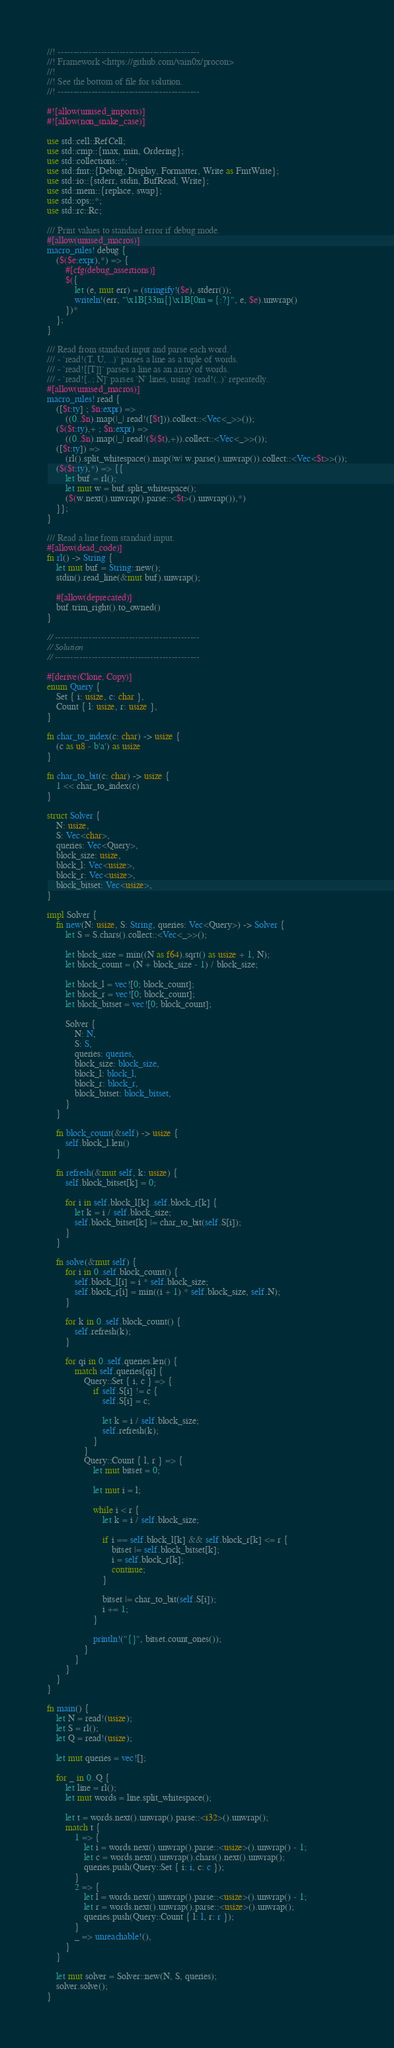<code> <loc_0><loc_0><loc_500><loc_500><_Rust_>//! ----------------------------------------------
//! Framework <https://github.com/vain0x/procon>
//!
//! See the bottom of file for solution.
//! ----------------------------------------------

#![allow(unused_imports)]
#![allow(non_snake_case)]

use std::cell::RefCell;
use std::cmp::{max, min, Ordering};
use std::collections::*;
use std::fmt::{Debug, Display, Formatter, Write as FmtWrite};
use std::io::{stderr, stdin, BufRead, Write};
use std::mem::{replace, swap};
use std::ops::*;
use std::rc::Rc;

/// Print values to standard error if debug mode.
#[allow(unused_macros)]
macro_rules! debug {
    ($($e:expr),*) => {
        #[cfg(debug_assertions)]
        $({
            let (e, mut err) = (stringify!($e), stderr());
            writeln!(err, "\x1B[33m{}\x1B[0m = {:?}", e, $e).unwrap()
        })*
    };
}

/// Read from standard input and parse each word.
/// - `read!(T, U, ..)` parses a line as a tuple of words.
/// - `read![[T]]` parses a line as an array of words.
/// - `read![..; N]` parses `N` lines, using `read!(..)` repeatedly.
#[allow(unused_macros)]
macro_rules! read {
    ([$t:ty] ; $n:expr) =>
        ((0..$n).map(|_| read!([$t])).collect::<Vec<_>>());
    ($($t:ty),+ ; $n:expr) =>
        ((0..$n).map(|_| read!($($t),+)).collect::<Vec<_>>());
    ([$t:ty]) =>
        (rl().split_whitespace().map(|w| w.parse().unwrap()).collect::<Vec<$t>>());
    ($($t:ty),*) => {{
        let buf = rl();
        let mut w = buf.split_whitespace();
        ($(w.next().unwrap().parse::<$t>().unwrap()),*)
    }};
}

/// Read a line from standard input.
#[allow(dead_code)]
fn rl() -> String {
    let mut buf = String::new();
    stdin().read_line(&mut buf).unwrap();

    #[allow(deprecated)]
    buf.trim_right().to_owned()
}

// -----------------------------------------------
// Solution
// -----------------------------------------------

#[derive(Clone, Copy)]
enum Query {
    Set { i: usize, c: char },
    Count { l: usize, r: usize },
}

fn char_to_index(c: char) -> usize {
    (c as u8 - b'a') as usize
}

fn char_to_bit(c: char) -> usize {
    1 << char_to_index(c)
}

struct Solver {
    N: usize,
    S: Vec<char>,
    queries: Vec<Query>,
    block_size: usize,
    block_l: Vec<usize>,
    block_r: Vec<usize>,
    block_bitset: Vec<usize>,
}

impl Solver {
    fn new(N: usize, S: String, queries: Vec<Query>) -> Solver {
        let S = S.chars().collect::<Vec<_>>();

        let block_size = min((N as f64).sqrt() as usize + 1, N);
        let block_count = (N + block_size - 1) / block_size;

        let block_l = vec![0; block_count];
        let block_r = vec![0; block_count];
        let block_bitset = vec![0; block_count];

        Solver {
            N: N,
            S: S,
            queries: queries,
            block_size: block_size,
            block_l: block_l,
            block_r: block_r,
            block_bitset: block_bitset,
        }
    }

    fn block_count(&self) -> usize {
        self.block_l.len()
    }

    fn refresh(&mut self, k: usize) {
        self.block_bitset[k] = 0;

        for i in self.block_l[k]..self.block_r[k] {
            let k = i / self.block_size;
            self.block_bitset[k] |= char_to_bit(self.S[i]);
        }
    }

    fn solve(&mut self) {
        for i in 0..self.block_count() {
            self.block_l[i] = i * self.block_size;
            self.block_r[i] = min((i + 1) * self.block_size, self.N);
        }

        for k in 0..self.block_count() {
            self.refresh(k);
        }

        for qi in 0..self.queries.len() {
            match self.queries[qi] {
                Query::Set { i, c } => {
                    if self.S[i] != c {
                        self.S[i] = c;

                        let k = i / self.block_size;
                        self.refresh(k);
                    }
                }
                Query::Count { l, r } => {
                    let mut bitset = 0;

                    let mut i = l;

                    while i < r {
                        let k = i / self.block_size;

                        if i == self.block_l[k] && self.block_r[k] <= r {
                            bitset |= self.block_bitset[k];
                            i = self.block_r[k];
                            continue;
                        }

                        bitset |= char_to_bit(self.S[i]);
                        i += 1;
                    }

                    println!("{}", bitset.count_ones());
                }
            }
        }
    }
}

fn main() {
    let N = read!(usize);
    let S = rl();
    let Q = read!(usize);

    let mut queries = vec![];

    for _ in 0..Q {
        let line = rl();
        let mut words = line.split_whitespace();

        let t = words.next().unwrap().parse::<i32>().unwrap();
        match t {
            1 => {
                let i = words.next().unwrap().parse::<usize>().unwrap() - 1;
                let c = words.next().unwrap().chars().next().unwrap();
                queries.push(Query::Set { i: i, c: c });
            }
            2 => {
                let l = words.next().unwrap().parse::<usize>().unwrap() - 1;
                let r = words.next().unwrap().parse::<usize>().unwrap();
                queries.push(Query::Count { l: l, r: r });
            }
            _ => unreachable!(),
        }
    }

    let mut solver = Solver::new(N, S, queries);
    solver.solve();
}
</code> 